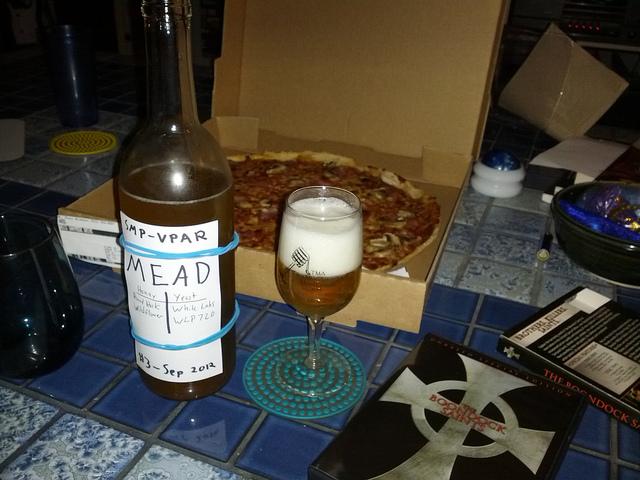Is someone making a smoothie?
Short answer required. No. Is this a white wine?
Quick response, please. No. Is that a whole pizza?
Short answer required. Yes. What movie is on the table?
Write a very short answer. Boondock saints. What is the table made of?
Write a very short answer. Tile. What brand of wine is this?
Keep it brief. Mead. What is in the glass?
Be succinct. Mead. 